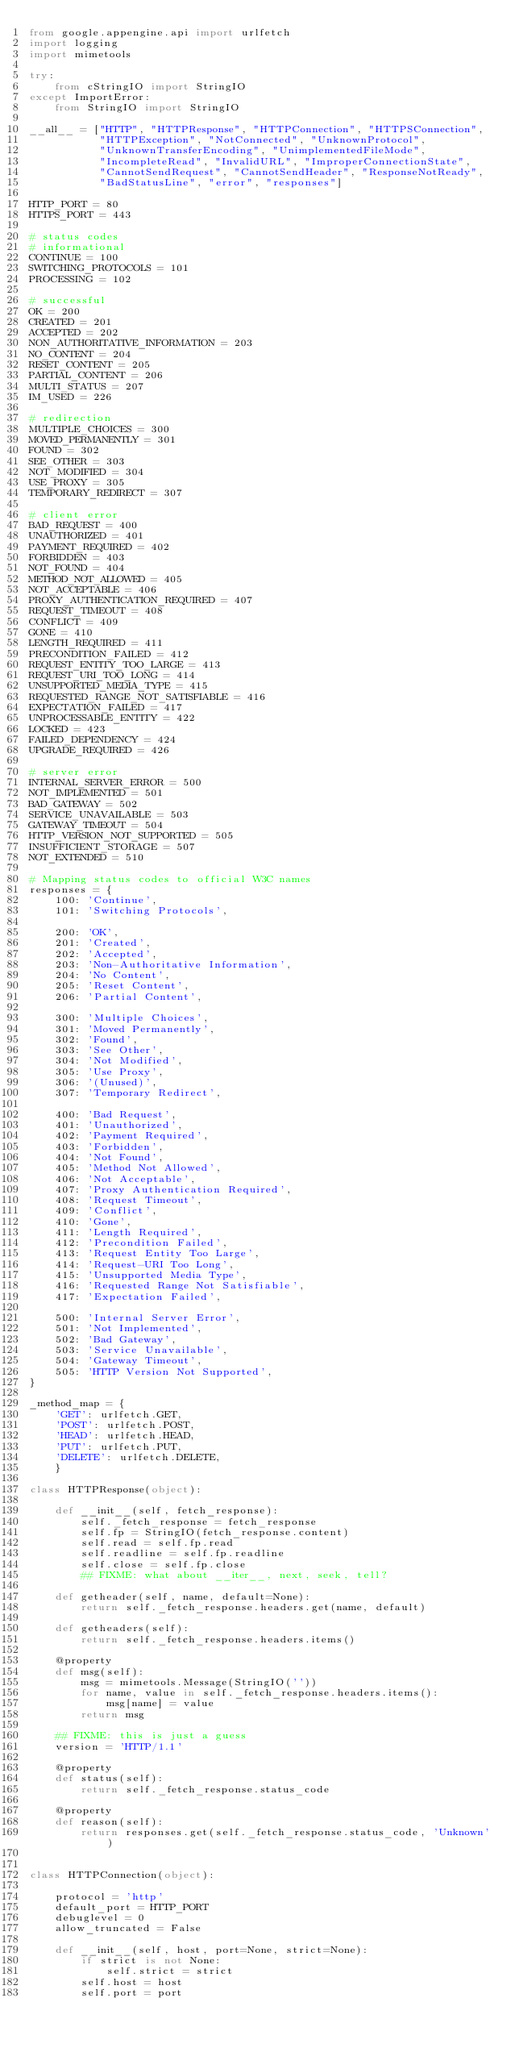Convert code to text. <code><loc_0><loc_0><loc_500><loc_500><_Python_>from google.appengine.api import urlfetch
import logging
import mimetools

try:
    from cStringIO import StringIO
except ImportError:
    from StringIO import StringIO

__all__ = ["HTTP", "HTTPResponse", "HTTPConnection", "HTTPSConnection",
           "HTTPException", "NotConnected", "UnknownProtocol",
           "UnknownTransferEncoding", "UnimplementedFileMode",
           "IncompleteRead", "InvalidURL", "ImproperConnectionState",
           "CannotSendRequest", "CannotSendHeader", "ResponseNotReady",
           "BadStatusLine", "error", "responses"]

HTTP_PORT = 80
HTTPS_PORT = 443

# status codes
# informational
CONTINUE = 100
SWITCHING_PROTOCOLS = 101
PROCESSING = 102

# successful
OK = 200
CREATED = 201
ACCEPTED = 202
NON_AUTHORITATIVE_INFORMATION = 203
NO_CONTENT = 204
RESET_CONTENT = 205
PARTIAL_CONTENT = 206
MULTI_STATUS = 207
IM_USED = 226

# redirection
MULTIPLE_CHOICES = 300
MOVED_PERMANENTLY = 301
FOUND = 302
SEE_OTHER = 303
NOT_MODIFIED = 304
USE_PROXY = 305
TEMPORARY_REDIRECT = 307

# client error
BAD_REQUEST = 400
UNAUTHORIZED = 401
PAYMENT_REQUIRED = 402
FORBIDDEN = 403
NOT_FOUND = 404
METHOD_NOT_ALLOWED = 405
NOT_ACCEPTABLE = 406
PROXY_AUTHENTICATION_REQUIRED = 407
REQUEST_TIMEOUT = 408
CONFLICT = 409
GONE = 410
LENGTH_REQUIRED = 411
PRECONDITION_FAILED = 412
REQUEST_ENTITY_TOO_LARGE = 413
REQUEST_URI_TOO_LONG = 414
UNSUPPORTED_MEDIA_TYPE = 415
REQUESTED_RANGE_NOT_SATISFIABLE = 416
EXPECTATION_FAILED = 417
UNPROCESSABLE_ENTITY = 422
LOCKED = 423
FAILED_DEPENDENCY = 424
UPGRADE_REQUIRED = 426

# server error
INTERNAL_SERVER_ERROR = 500
NOT_IMPLEMENTED = 501
BAD_GATEWAY = 502
SERVICE_UNAVAILABLE = 503
GATEWAY_TIMEOUT = 504
HTTP_VERSION_NOT_SUPPORTED = 505
INSUFFICIENT_STORAGE = 507
NOT_EXTENDED = 510

# Mapping status codes to official W3C names
responses = {
    100: 'Continue',
    101: 'Switching Protocols',

    200: 'OK',
    201: 'Created',
    202: 'Accepted',
    203: 'Non-Authoritative Information',
    204: 'No Content',
    205: 'Reset Content',
    206: 'Partial Content',

    300: 'Multiple Choices',
    301: 'Moved Permanently',
    302: 'Found',
    303: 'See Other',
    304: 'Not Modified',
    305: 'Use Proxy',
    306: '(Unused)',
    307: 'Temporary Redirect',

    400: 'Bad Request',
    401: 'Unauthorized',
    402: 'Payment Required',
    403: 'Forbidden',
    404: 'Not Found',
    405: 'Method Not Allowed',
    406: 'Not Acceptable',
    407: 'Proxy Authentication Required',
    408: 'Request Timeout',
    409: 'Conflict',
    410: 'Gone',
    411: 'Length Required',
    412: 'Precondition Failed',
    413: 'Request Entity Too Large',
    414: 'Request-URI Too Long',
    415: 'Unsupported Media Type',
    416: 'Requested Range Not Satisfiable',
    417: 'Expectation Failed',

    500: 'Internal Server Error',
    501: 'Not Implemented',
    502: 'Bad Gateway',
    503: 'Service Unavailable',
    504: 'Gateway Timeout',
    505: 'HTTP Version Not Supported',
}

_method_map = {
    'GET': urlfetch.GET,
    'POST': urlfetch.POST,
    'HEAD': urlfetch.HEAD,
    'PUT': urlfetch.PUT,
    'DELETE': urlfetch.DELETE,
    }

class HTTPResponse(object):

    def __init__(self, fetch_response):
        self._fetch_response = fetch_response
        self.fp = StringIO(fetch_response.content)
        self.read = self.fp.read
        self.readline = self.fp.readline
        self.close = self.fp.close
        ## FIXME: what about __iter__, next, seek, tell?

    def getheader(self, name, default=None):
        return self._fetch_response.headers.get(name, default)

    def getheaders(self):
        return self._fetch_response.headers.items()

    @property
    def msg(self):
        msg = mimetools.Message(StringIO(''))
        for name, value in self._fetch_response.headers.items():
            msg[name] = value
        return msg

    ## FIXME: this is just a guess
    version = 'HTTP/1.1'

    @property
    def status(self):
        return self._fetch_response.status_code

    @property
    def reason(self):
        return responses.get(self._fetch_response.status_code, 'Unknown')
    

class HTTPConnection(object):

    protocol = 'http'
    default_port = HTTP_PORT
    debuglevel = 0
    allow_truncated = False

    def __init__(self, host, port=None, strict=None):
        if strict is not None:
            self.strict = strict
        self.host = host
        self.port = port</code> 